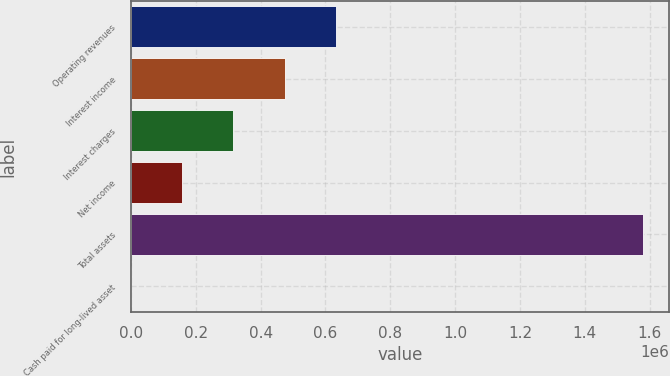Convert chart to OTSL. <chart><loc_0><loc_0><loc_500><loc_500><bar_chart><fcel>Operating revenues<fcel>Interest income<fcel>Interest charges<fcel>Net income<fcel>Total assets<fcel>Cash paid for long-lived asset<nl><fcel>632506<fcel>474381<fcel>316256<fcel>158130<fcel>1.58126e+06<fcel>5<nl></chart> 